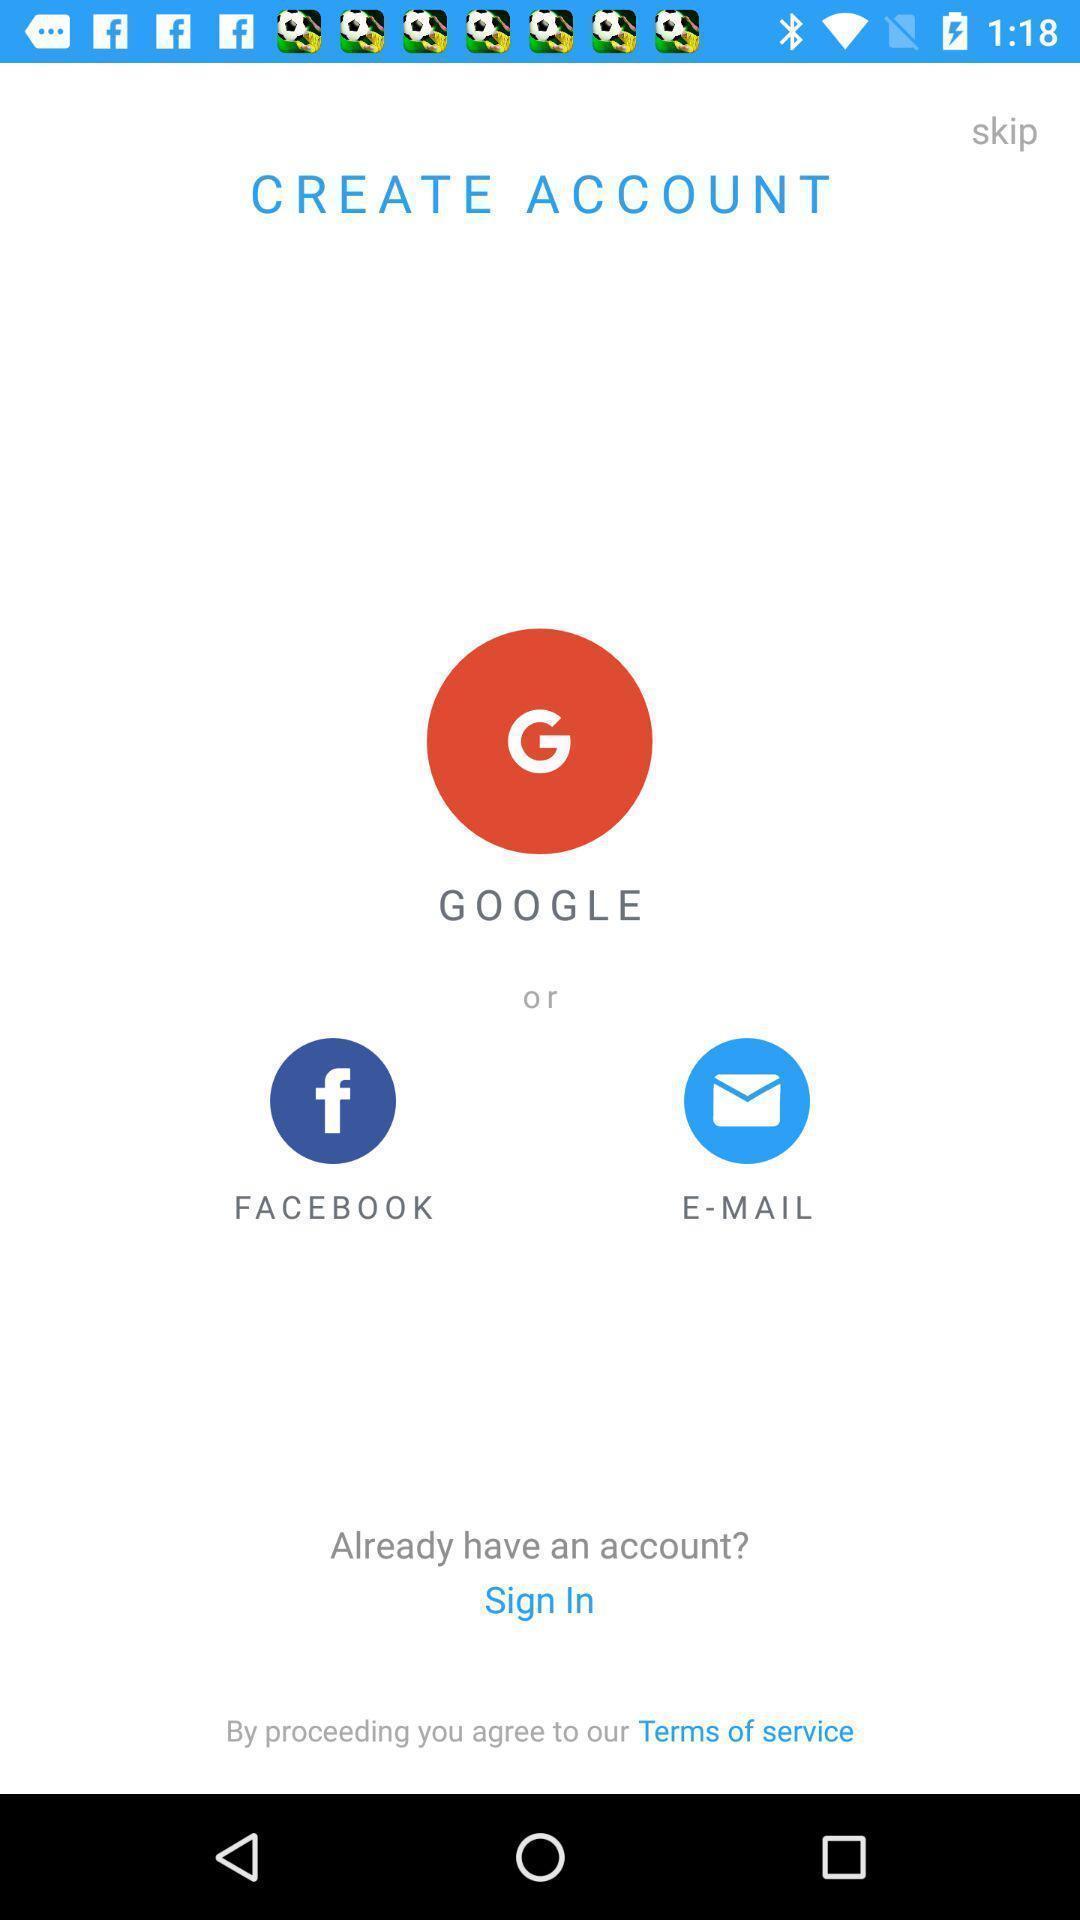Summarize the information in this screenshot. Welcome page with login or signup options. 